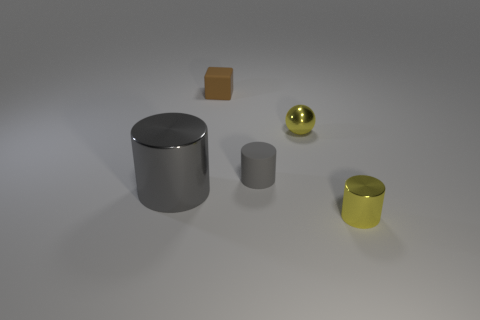Can you describe the shapes and their relative sizes seen in the image? Certainly! The image displays a collection of geometric shapes. There's a large cylinder, a smaller cylinder, a cube, and a sphere. The sphere and cube are similar in size, modest compared to both cylinders, with the larger cylinder being the most prominent object due to its size and central placement. 